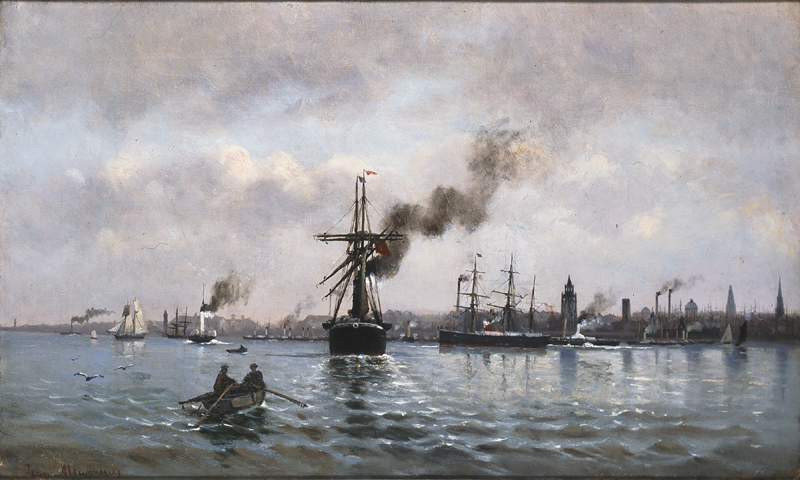Can you point out anything in the background of the painting that gives us a hint about the location? In the background of the painting, you can see several landmarks that provide clues about its location. The style of the buildings and the presence of prominent historical buildings suggest this scene might be set in a European harbor, possibly during the industrial age given the smokestacks and steam-powered boats. 